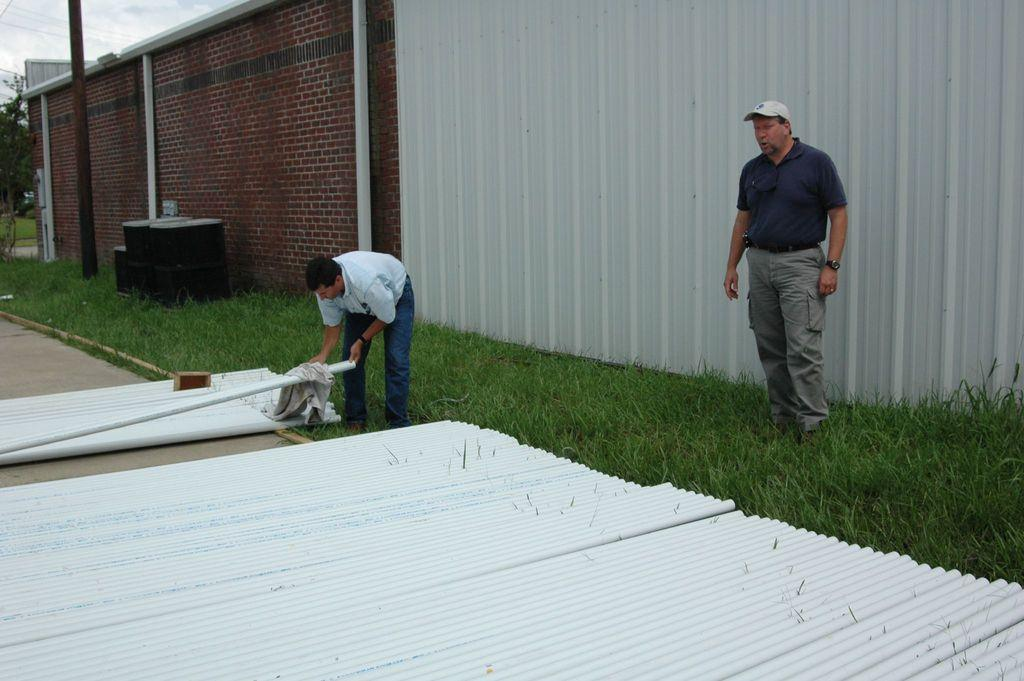How many men are in the image? There are two men standing in the image. What is the ground surface like where the men are standing? The men are standing on grass. What type of construction material is present in the image? Roof sheets and a brick wall are present in the image. What other objects can be seen in the image? A pole is visible in the image. What type of vegetation is present in the image? Trees are present in the image. What is visible in the background of the image? The sky with clouds is visible in the background of the image. How many kittens are sitting on the pole in the image? There are no kittens present in the image; only the two men, grass, roof sheets, brick wall, pole, trees, and sky with clouds are visible. 